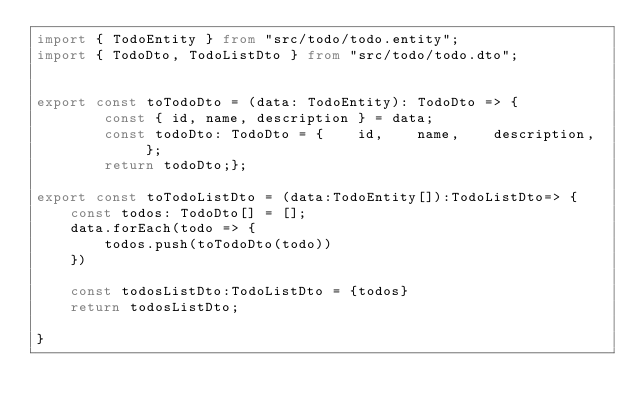Convert code to text. <code><loc_0><loc_0><loc_500><loc_500><_TypeScript_>import { TodoEntity } from "src/todo/todo.entity";
import { TodoDto, TodoListDto } from "src/todo/todo.dto";


export const toTodoDto = (data: TodoEntity): TodoDto => {  
        const { id, name, description } = data;
        const todoDto: TodoDto = {    id,    name,    description,  };
        return todoDto;};

export const toTodoListDto = (data:TodoEntity[]):TodoListDto=> {
    const todos: TodoDto[] = [];
    data.forEach(todo => {
        todos.push(toTodoDto(todo))
    })
    
    const todosListDto:TodoListDto = {todos} 
    return todosListDto;

}
  </code> 